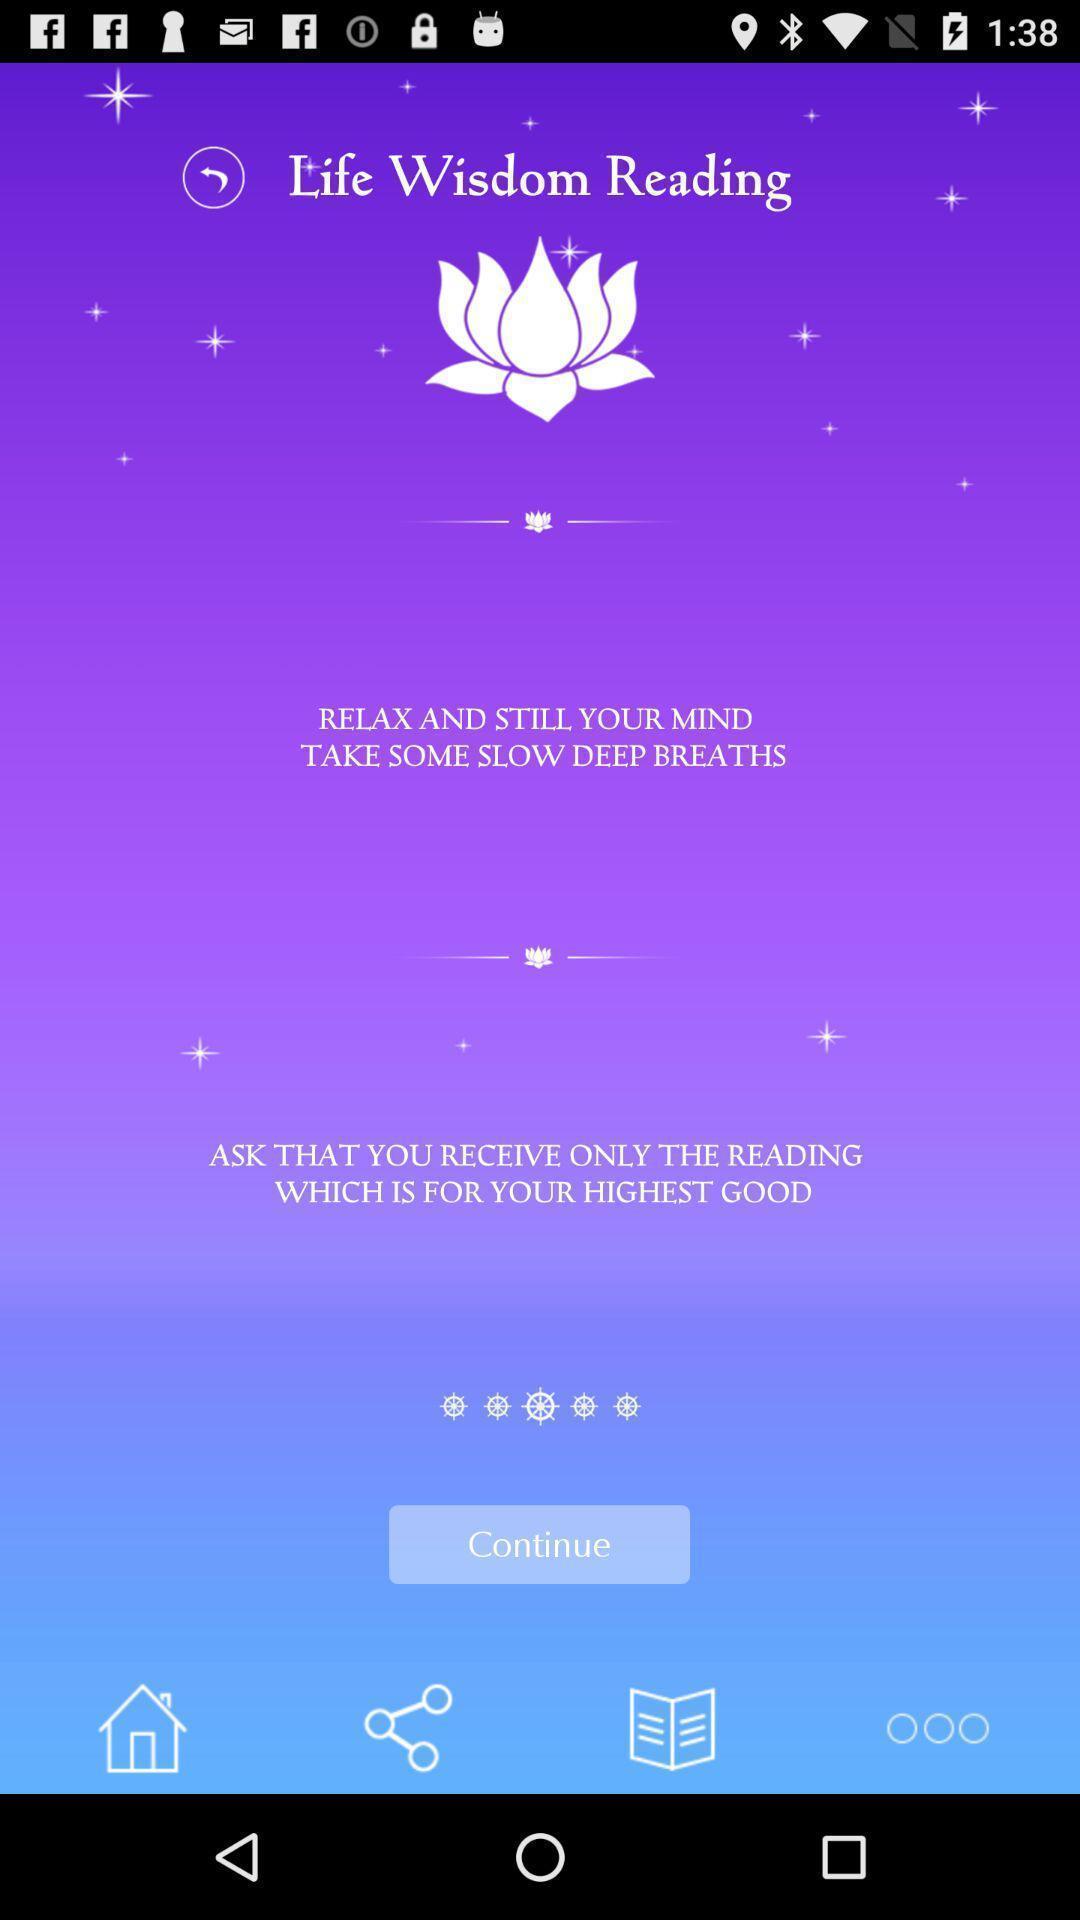What can you discern from this picture? Welcome page of a reading app. 